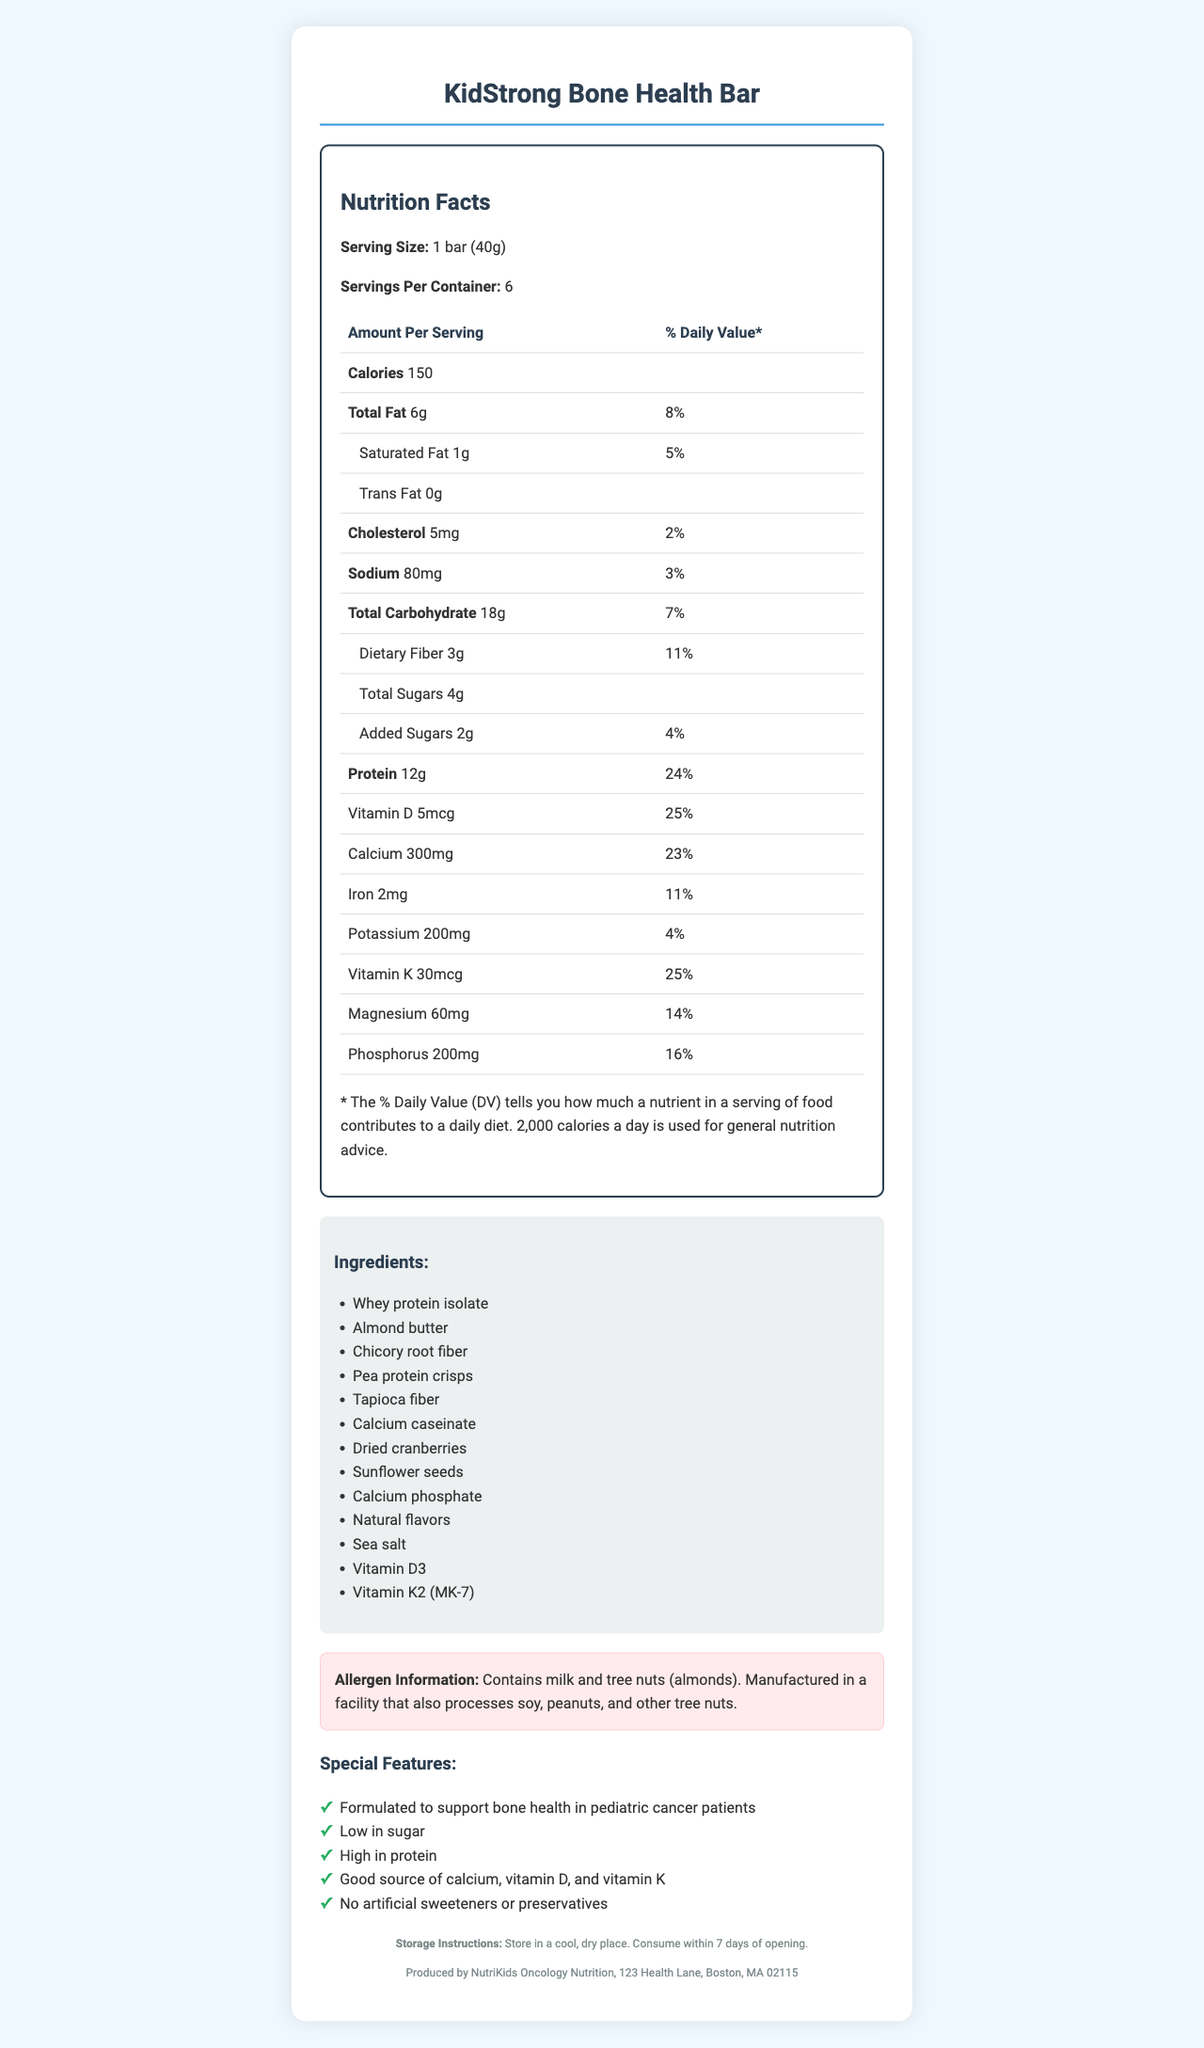what is the serving size of the KidStrong Bone Health Bar? The serving size is mentioned as "1 bar (40g)" in the document.
Answer: 1 bar (40g) what is the total amount of protein per serving? The document indicates that each serving of the KidStrong Bone Health Bar contains 12g of protein.
Answer: 12g name two main ingredients in the KidStrong Bone Health Bar. The ingredients list includes "Whey protein isolate" and "Almond butter" among others.
Answer: Whey protein isolate, Almond butter how many calories are there per serving of the KidStrong Bone Health Bar? The document shows that one serving (1 bar) contains 150 calories.
Answer: 150 what special features does the KidStrong Bone Health Bar have? The special features listed in the document describe these specific points.
Answer: Formulated to support bone health in pediatric cancer patients, Low in sugar, High in protein, Good source of calcium, vitamin D, and vitamin K, No artificial sweeteners or preservatives how much dietary fiber is in each serving? The amount of dietary fiber per serving is listed as 3g.
Answer: 3g is the KidStrong Bone Health Bar suitable for people allergic to milk? The allergen information section indicates that the product contains milk, making it unsuitable for people with milk allergies.
Answer: No what percentage of vitamin D's daily value does the bar provide? A. 10% B. 15% C. 25% D. 30% The nutrition facts table states that the bar provides 25% of the daily value for vitamin D.
Answer: C. 25% what should be the storage conditions for the KidStrong Bone Health Bar? A. Refrigerate upon opening B. Store in a cool, dry place C. Keep in the freezer D. Store at room temperature The storage instructions specify that the bar should be stored in a cool, dry place.
Answer: B. Store in a cool, dry place how much total carbohydrate does one bar contain? The total carbohydrate content per serving is 18g according to the document.
Answer: 18g are there any artificial sweeteners in the KidStrong Bone Health Bar? One of the special features listed is "No artificial sweeteners or preservatives."
Answer: No does the KidStrong Bone Health Bar contain peanuts? The allergen information says it is manufactured in a facility that processes peanuts, but it does not state if peanuts are in the bar itself.
Answer: Cannot be determined summarize the key points of the KidStrong Bone Health Bar document. This summary pulls together the primary features, nutritional information, ingredients, allergen details, special features, and storage instructions of the product as listed in the document.
Answer: The KidStrong Bone Health Bar is designed for pediatric cancer patients to support bone health. Each bar has a serving size of 40g, providing 150 calories, 6g total fat, 12g protein, and 18g total carbohydrate (including 3g dietary fiber and 4g sugars). Vitamins and minerals such as vitamin D (25% DV), calcium (23% DV), and vitamin K (25% DV) are included. The ingredients list features whey protein isolate and almond butter, among others, and the product contains milk and tree nuts. Other key characteristics are its low sugar content, absence of artificial sweeteners, and specific storage instructions. 